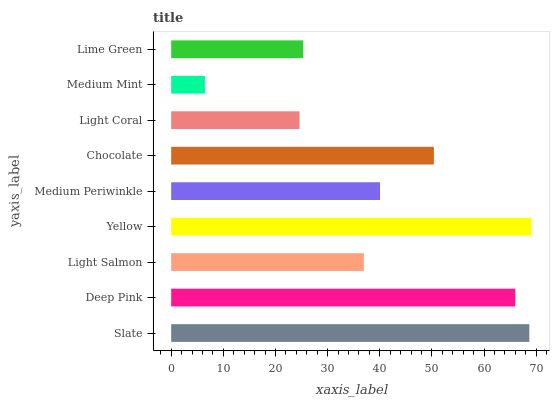Is Medium Mint the minimum?
Answer yes or no. Yes. Is Yellow the maximum?
Answer yes or no. Yes. Is Deep Pink the minimum?
Answer yes or no. No. Is Deep Pink the maximum?
Answer yes or no. No. Is Slate greater than Deep Pink?
Answer yes or no. Yes. Is Deep Pink less than Slate?
Answer yes or no. Yes. Is Deep Pink greater than Slate?
Answer yes or no. No. Is Slate less than Deep Pink?
Answer yes or no. No. Is Medium Periwinkle the high median?
Answer yes or no. Yes. Is Medium Periwinkle the low median?
Answer yes or no. Yes. Is Lime Green the high median?
Answer yes or no. No. Is Lime Green the low median?
Answer yes or no. No. 